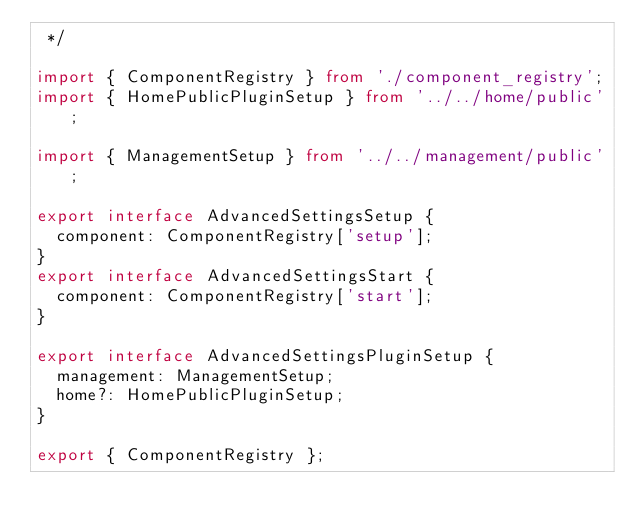Convert code to text. <code><loc_0><loc_0><loc_500><loc_500><_TypeScript_> */

import { ComponentRegistry } from './component_registry';
import { HomePublicPluginSetup } from '../../home/public';

import { ManagementSetup } from '../../management/public';

export interface AdvancedSettingsSetup {
  component: ComponentRegistry['setup'];
}
export interface AdvancedSettingsStart {
  component: ComponentRegistry['start'];
}

export interface AdvancedSettingsPluginSetup {
  management: ManagementSetup;
  home?: HomePublicPluginSetup;
}

export { ComponentRegistry };
</code> 